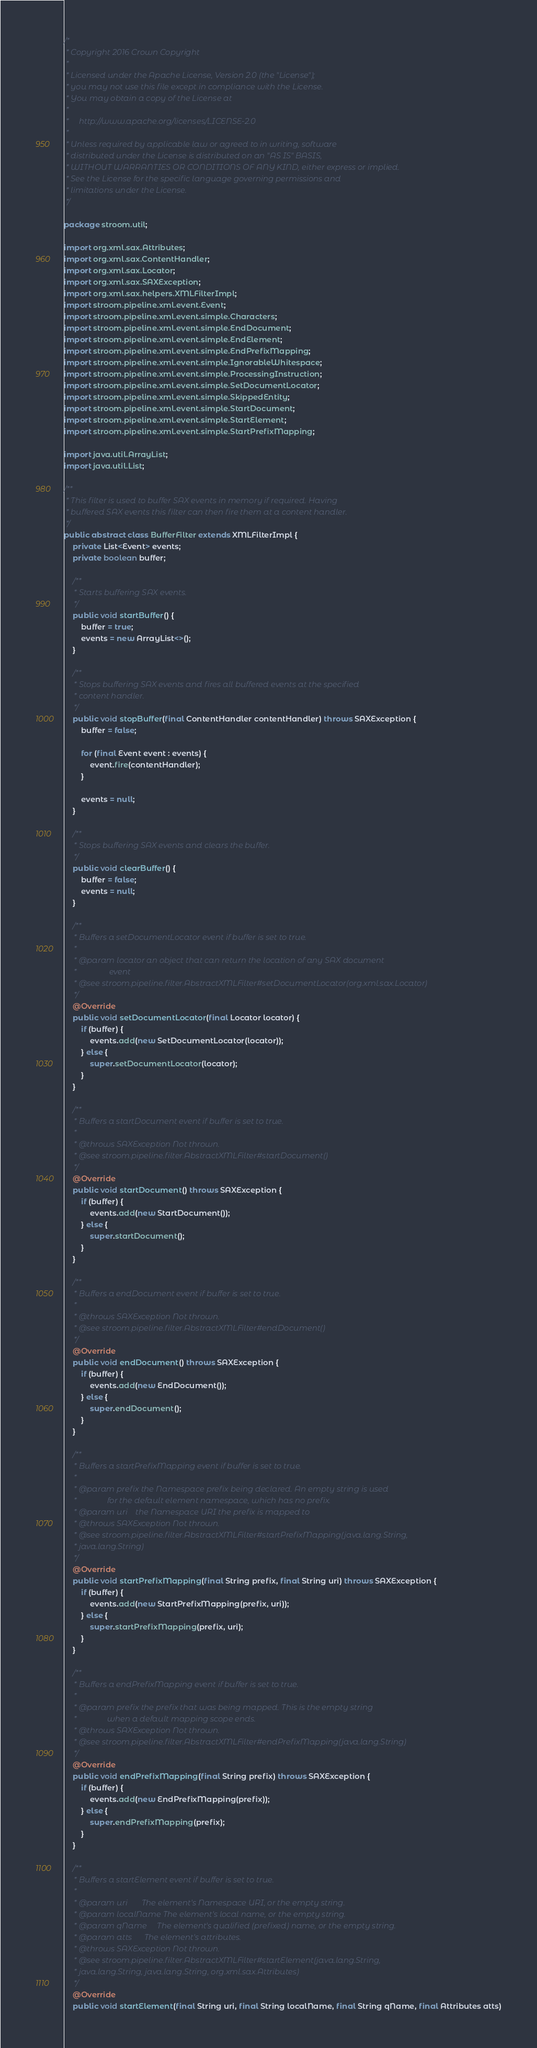<code> <loc_0><loc_0><loc_500><loc_500><_Java_>/*
 * Copyright 2016 Crown Copyright
 *
 * Licensed under the Apache License, Version 2.0 (the "License");
 * you may not use this file except in compliance with the License.
 * You may obtain a copy of the License at
 *
 *     http://www.apache.org/licenses/LICENSE-2.0
 *
 * Unless required by applicable law or agreed to in writing, software
 * distributed under the License is distributed on an "AS IS" BASIS,
 * WITHOUT WARRANTIES OR CONDITIONS OF ANY KIND, either express or implied.
 * See the License for the specific language governing permissions and
 * limitations under the License.
 */

package stroom.util;

import org.xml.sax.Attributes;
import org.xml.sax.ContentHandler;
import org.xml.sax.Locator;
import org.xml.sax.SAXException;
import org.xml.sax.helpers.XMLFilterImpl;
import stroom.pipeline.xml.event.Event;
import stroom.pipeline.xml.event.simple.Characters;
import stroom.pipeline.xml.event.simple.EndDocument;
import stroom.pipeline.xml.event.simple.EndElement;
import stroom.pipeline.xml.event.simple.EndPrefixMapping;
import stroom.pipeline.xml.event.simple.IgnorableWhitespace;
import stroom.pipeline.xml.event.simple.ProcessingInstruction;
import stroom.pipeline.xml.event.simple.SetDocumentLocator;
import stroom.pipeline.xml.event.simple.SkippedEntity;
import stroom.pipeline.xml.event.simple.StartDocument;
import stroom.pipeline.xml.event.simple.StartElement;
import stroom.pipeline.xml.event.simple.StartPrefixMapping;

import java.util.ArrayList;
import java.util.List;

/**
 * This filter is used to buffer SAX events in memory if required. Having
 * buffered SAX events this filter can then fire them at a content handler.
 */
public abstract class BufferFilter extends XMLFilterImpl {
    private List<Event> events;
    private boolean buffer;

    /**
     * Starts buffering SAX events.
     */
    public void startBuffer() {
        buffer = true;
        events = new ArrayList<>();
    }

    /**
     * Stops buffering SAX events and fires all buffered events at the specified
     * content handler.
     */
    public void stopBuffer(final ContentHandler contentHandler) throws SAXException {
        buffer = false;

        for (final Event event : events) {
            event.fire(contentHandler);
        }

        events = null;
    }

    /**
     * Stops buffering SAX events and clears the buffer.
     */
    public void clearBuffer() {
        buffer = false;
        events = null;
    }

    /**
     * Buffers a setDocumentLocator event if buffer is set to true.
     *
     * @param locator an object that can return the location of any SAX document
     *                event
     * @see stroom.pipeline.filter.AbstractXMLFilter#setDocumentLocator(org.xml.sax.Locator)
     */
    @Override
    public void setDocumentLocator(final Locator locator) {
        if (buffer) {
            events.add(new SetDocumentLocator(locator));
        } else {
            super.setDocumentLocator(locator);
        }
    }

    /**
     * Buffers a startDocument event if buffer is set to true.
     *
     * @throws SAXException Not thrown.
     * @see stroom.pipeline.filter.AbstractXMLFilter#startDocument()
     */
    @Override
    public void startDocument() throws SAXException {
        if (buffer) {
            events.add(new StartDocument());
        } else {
            super.startDocument();
        }
    }

    /**
     * Buffers a endDocument event if buffer is set to true.
     *
     * @throws SAXException Not thrown.
     * @see stroom.pipeline.filter.AbstractXMLFilter#endDocument()
     */
    @Override
    public void endDocument() throws SAXException {
        if (buffer) {
            events.add(new EndDocument());
        } else {
            super.endDocument();
        }
    }

    /**
     * Buffers a startPrefixMapping event if buffer is set to true.
     *
     * @param prefix the Namespace prefix being declared. An empty string is used
     *               for the default element namespace, which has no prefix.
     * @param uri    the Namespace URI the prefix is mapped to
     * @throws SAXException Not thrown.
     * @see stroom.pipeline.filter.AbstractXMLFilter#startPrefixMapping(java.lang.String,
     * java.lang.String)
     */
    @Override
    public void startPrefixMapping(final String prefix, final String uri) throws SAXException {
        if (buffer) {
            events.add(new StartPrefixMapping(prefix, uri));
        } else {
            super.startPrefixMapping(prefix, uri);
        }
    }

    /**
     * Buffers a endPrefixMapping event if buffer is set to true.
     *
     * @param prefix the prefix that was being mapped. This is the empty string
     *               when a default mapping scope ends.
     * @throws SAXException Not thrown.
     * @see stroom.pipeline.filter.AbstractXMLFilter#endPrefixMapping(java.lang.String)
     */
    @Override
    public void endPrefixMapping(final String prefix) throws SAXException {
        if (buffer) {
            events.add(new EndPrefixMapping(prefix));
        } else {
            super.endPrefixMapping(prefix);
        }
    }

    /**
     * Buffers a startElement event if buffer is set to true.
     *
     * @param uri       The element's Namespace URI, or the empty string.
     * @param localName The element's local name, or the empty string.
     * @param qName     The element's qualified (prefixed) name, or the empty string.
     * @param atts      The element's attributes.
     * @throws SAXException Not thrown.
     * @see stroom.pipeline.filter.AbstractXMLFilter#startElement(java.lang.String,
     * java.lang.String, java.lang.String, org.xml.sax.Attributes)
     */
    @Override
    public void startElement(final String uri, final String localName, final String qName, final Attributes atts)</code> 